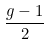<formula> <loc_0><loc_0><loc_500><loc_500>\frac { g - 1 } { 2 }</formula> 